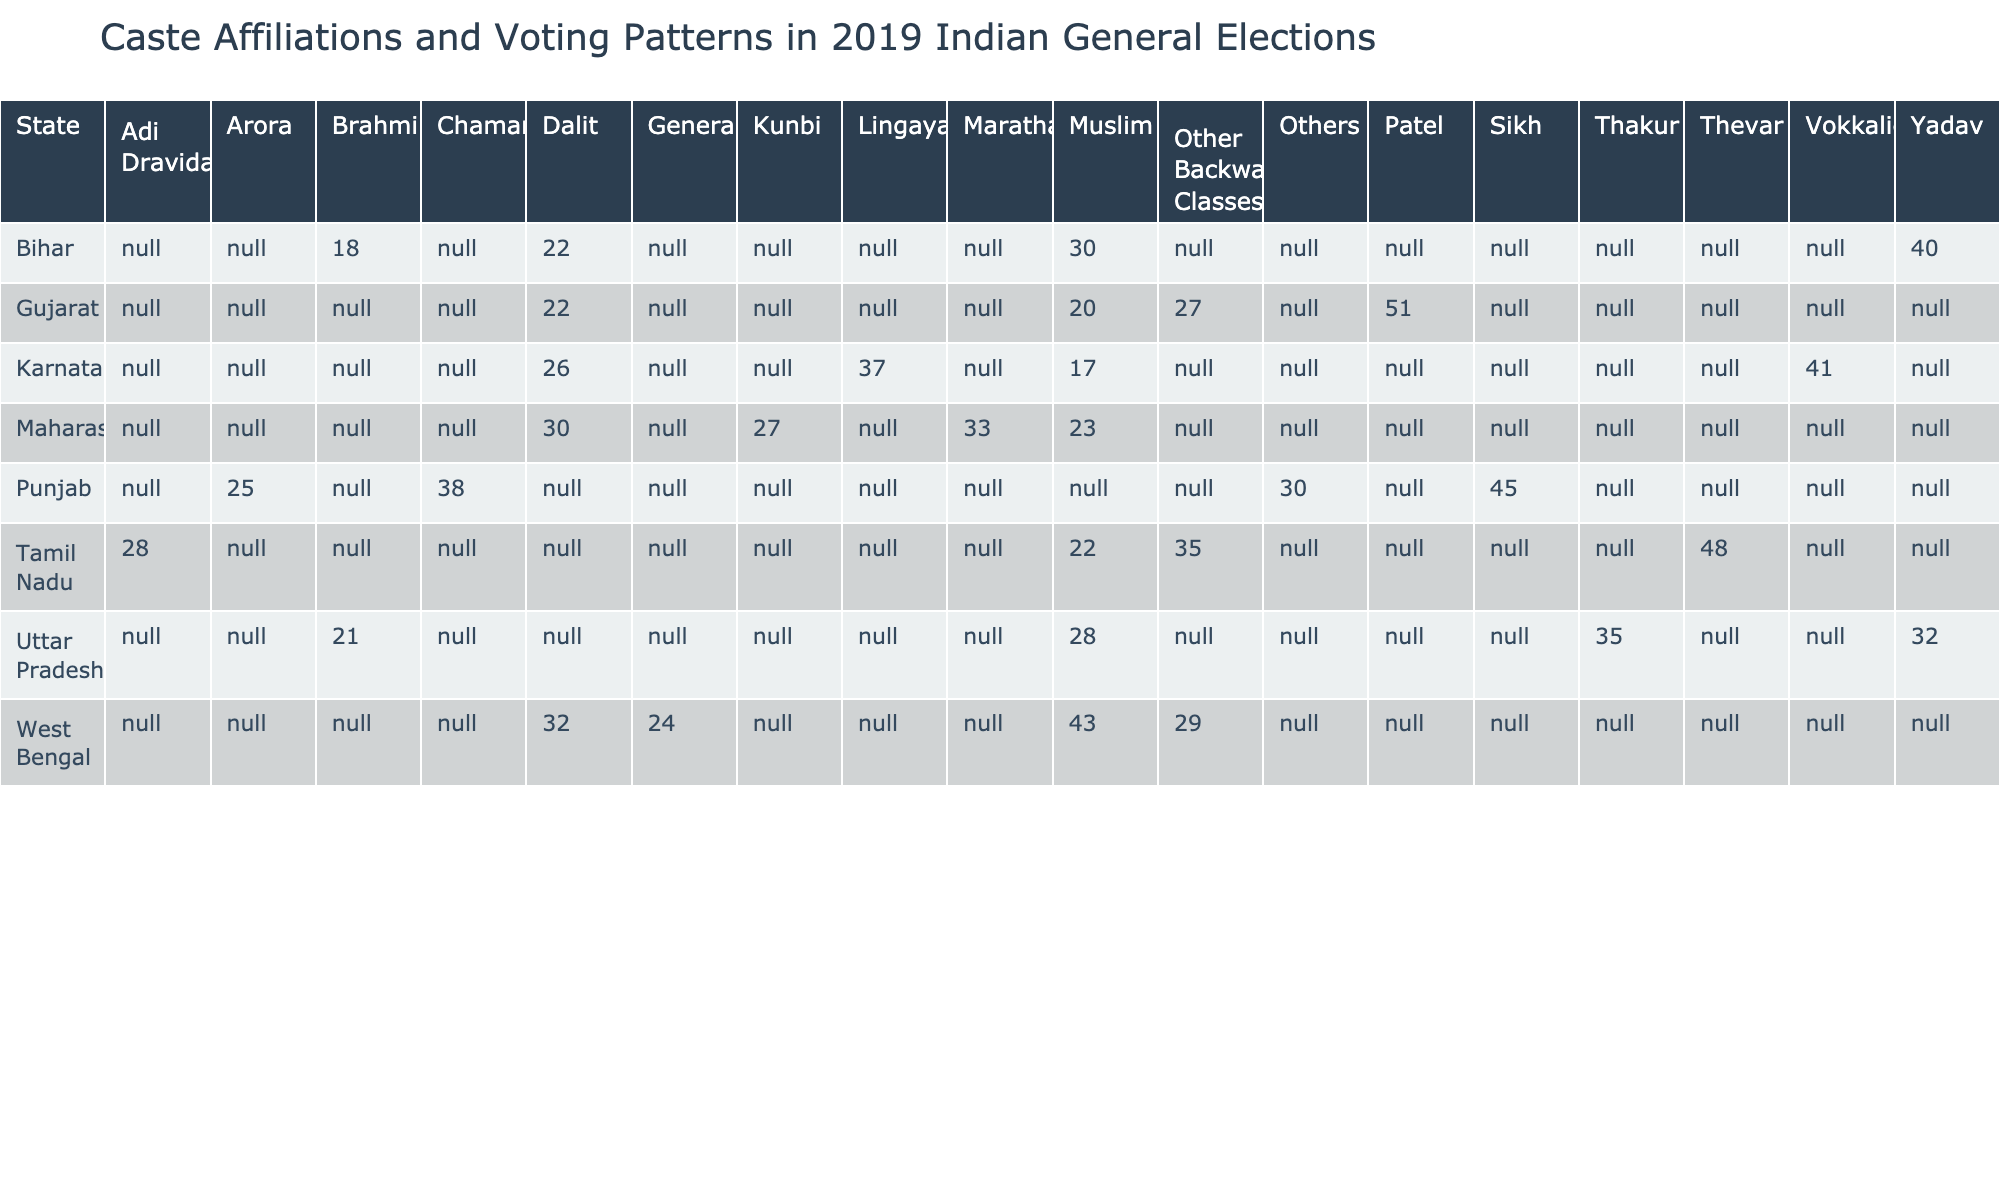What is the vote percentage for Yadav in Bihar? The vote percentage for Yadav can be found in the Bihar row under the Yadav column. It shows a value of 40.
Answer: 40 Which caste had the highest vote percentage in Gujarat? In the Gujarat row, the Patel caste has the highest vote percentage of 51, which is greater than the other castes listed for the state.
Answer: 51 What is the average vote percentage of Dalits across all states? To find the average vote percentage for Dalits, I need to sum the Dalit percentages from all states: Uttar Pradesh (0), Maharashtra (30), Bihar (22), West Bengal (32), Punjab (38), Tamil Nadu (28), Karnataka (26), and Gujarat (22). This gives a total of 0 + 30 + 22 + 32 + 38 + 28 + 26 + 22 = 198. There are 8 entries, so the average is 198 / 8 = 24.75.
Answer: 24.75 Did Muslims have a higher vote percentage in West Bengal than in Maharashtra? In West Bengal, the Muslim vote percentage is 43, while in Maharashtra it is 23. Since 43 is greater than 23, the statement is true.
Answer: Yes What is the difference in vote percentage between Thakur and Muslim castes in Uttar Pradesh? In Uttar Pradesh, the Thakur caste has a vote percentage of 35 while the Muslim caste has a percentage of 28. The difference is calculated by subtracting 28 from 35, which results in 7.
Answer: 7 Which state had the lowest vote percentage for Dalits? To answer this, I will look at the Dalit percentages across states: Uttar Pradesh (0), Maharashtra (30), Bihar (22), West Bengal (32), Punjab (38), Tamil Nadu (28), Karnataka (26), and Gujarat (22). The lowest value is found in Uttar Pradesh, which has a vote percentage of 0.
Answer: Uttar Pradesh What is the total vote percentage for the Sikh caste in Punjab compared to the vote percentage for the General caste in West Bengal? The Sikh caste in Punjab has a vote percentage of 45, while the General caste in West Bengal has a percentage of 24. The total for the Sikh caste is higher than that of the General caste by 21.
Answer: 21 How does the vote percentage for Vokkaliga in Karnataka compare to that of Thakur in Uttar Pradesh? The vote percentage for Vokkaliga in Karnataka is 41 while the Thakur in Uttar Pradesh has 35. Comparing these, Vokkaliga has a higher vote percentage by 6.
Answer: 6 